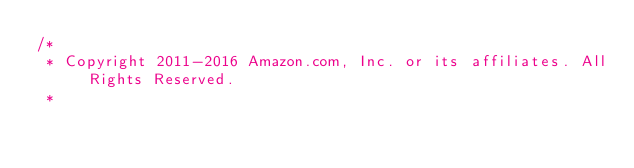<code> <loc_0><loc_0><loc_500><loc_500><_Java_>/*
 * Copyright 2011-2016 Amazon.com, Inc. or its affiliates. All Rights Reserved.
 * </code> 